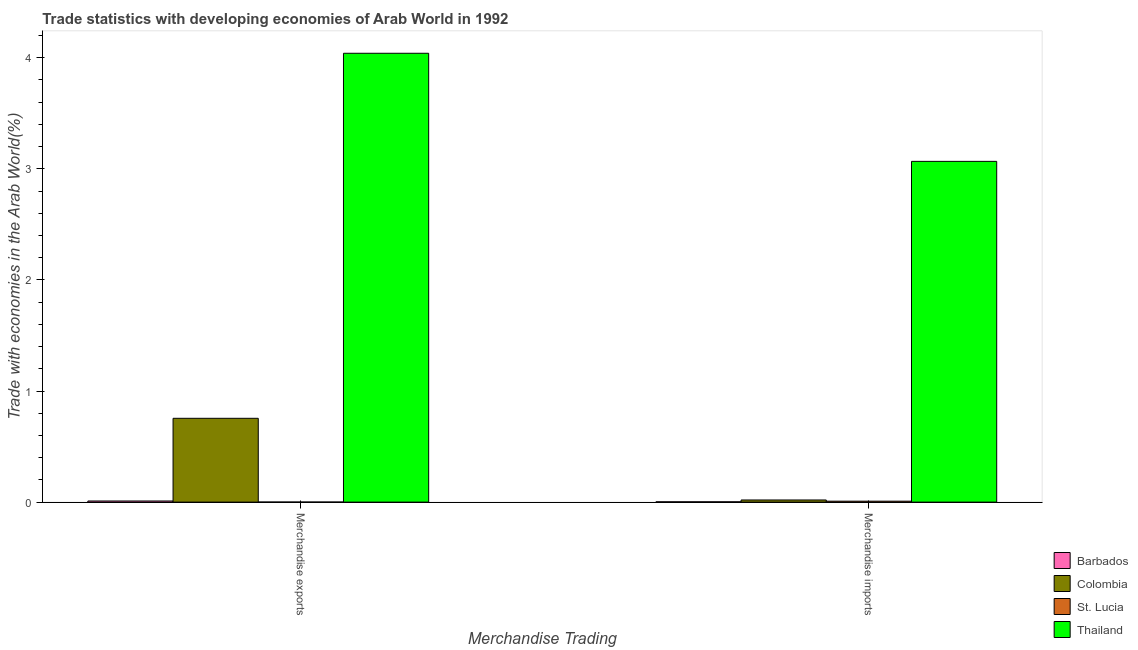How many different coloured bars are there?
Offer a very short reply. 4. How many groups of bars are there?
Ensure brevity in your answer.  2. Are the number of bars per tick equal to the number of legend labels?
Provide a short and direct response. Yes. How many bars are there on the 2nd tick from the right?
Make the answer very short. 4. What is the merchandise exports in Colombia?
Your answer should be compact. 0.75. Across all countries, what is the maximum merchandise exports?
Your answer should be very brief. 4.04. Across all countries, what is the minimum merchandise exports?
Keep it short and to the point. 0. In which country was the merchandise exports maximum?
Your response must be concise. Thailand. In which country was the merchandise imports minimum?
Your answer should be very brief. Barbados. What is the total merchandise exports in the graph?
Give a very brief answer. 4.8. What is the difference between the merchandise exports in Thailand and that in St. Lucia?
Offer a terse response. 4.04. What is the difference between the merchandise imports in St. Lucia and the merchandise exports in Colombia?
Your response must be concise. -0.75. What is the average merchandise imports per country?
Provide a succinct answer. 0.77. What is the difference between the merchandise imports and merchandise exports in Colombia?
Offer a terse response. -0.73. What is the ratio of the merchandise imports in Thailand to that in St. Lucia?
Provide a succinct answer. 362.38. What does the 1st bar from the right in Merchandise exports represents?
Your answer should be compact. Thailand. Are the values on the major ticks of Y-axis written in scientific E-notation?
Ensure brevity in your answer.  No. Does the graph contain grids?
Ensure brevity in your answer.  No. Where does the legend appear in the graph?
Offer a very short reply. Bottom right. What is the title of the graph?
Give a very brief answer. Trade statistics with developing economies of Arab World in 1992. What is the label or title of the X-axis?
Keep it short and to the point. Merchandise Trading. What is the label or title of the Y-axis?
Provide a succinct answer. Trade with economies in the Arab World(%). What is the Trade with economies in the Arab World(%) of Barbados in Merchandise exports?
Provide a succinct answer. 0.01. What is the Trade with economies in the Arab World(%) in Colombia in Merchandise exports?
Give a very brief answer. 0.75. What is the Trade with economies in the Arab World(%) in St. Lucia in Merchandise exports?
Keep it short and to the point. 0. What is the Trade with economies in the Arab World(%) of Thailand in Merchandise exports?
Your answer should be very brief. 4.04. What is the Trade with economies in the Arab World(%) of Barbados in Merchandise imports?
Offer a very short reply. 0. What is the Trade with economies in the Arab World(%) of Colombia in Merchandise imports?
Give a very brief answer. 0.02. What is the Trade with economies in the Arab World(%) of St. Lucia in Merchandise imports?
Your answer should be compact. 0.01. What is the Trade with economies in the Arab World(%) in Thailand in Merchandise imports?
Make the answer very short. 3.07. Across all Merchandise Trading, what is the maximum Trade with economies in the Arab World(%) in Barbados?
Your answer should be compact. 0.01. Across all Merchandise Trading, what is the maximum Trade with economies in the Arab World(%) of Colombia?
Your response must be concise. 0.75. Across all Merchandise Trading, what is the maximum Trade with economies in the Arab World(%) of St. Lucia?
Ensure brevity in your answer.  0.01. Across all Merchandise Trading, what is the maximum Trade with economies in the Arab World(%) of Thailand?
Your answer should be compact. 4.04. Across all Merchandise Trading, what is the minimum Trade with economies in the Arab World(%) in Barbados?
Provide a short and direct response. 0. Across all Merchandise Trading, what is the minimum Trade with economies in the Arab World(%) in Colombia?
Make the answer very short. 0.02. Across all Merchandise Trading, what is the minimum Trade with economies in the Arab World(%) in St. Lucia?
Offer a terse response. 0. Across all Merchandise Trading, what is the minimum Trade with economies in the Arab World(%) of Thailand?
Offer a very short reply. 3.07. What is the total Trade with economies in the Arab World(%) of Barbados in the graph?
Give a very brief answer. 0.01. What is the total Trade with economies in the Arab World(%) of Colombia in the graph?
Provide a short and direct response. 0.77. What is the total Trade with economies in the Arab World(%) of St. Lucia in the graph?
Give a very brief answer. 0.01. What is the total Trade with economies in the Arab World(%) of Thailand in the graph?
Give a very brief answer. 7.11. What is the difference between the Trade with economies in the Arab World(%) of Barbados in Merchandise exports and that in Merchandise imports?
Your response must be concise. 0.01. What is the difference between the Trade with economies in the Arab World(%) of Colombia in Merchandise exports and that in Merchandise imports?
Provide a succinct answer. 0.73. What is the difference between the Trade with economies in the Arab World(%) of St. Lucia in Merchandise exports and that in Merchandise imports?
Offer a very short reply. -0.01. What is the difference between the Trade with economies in the Arab World(%) of Thailand in Merchandise exports and that in Merchandise imports?
Ensure brevity in your answer.  0.97. What is the difference between the Trade with economies in the Arab World(%) of Barbados in Merchandise exports and the Trade with economies in the Arab World(%) of Colombia in Merchandise imports?
Your answer should be compact. -0.01. What is the difference between the Trade with economies in the Arab World(%) in Barbados in Merchandise exports and the Trade with economies in the Arab World(%) in St. Lucia in Merchandise imports?
Give a very brief answer. 0. What is the difference between the Trade with economies in the Arab World(%) in Barbados in Merchandise exports and the Trade with economies in the Arab World(%) in Thailand in Merchandise imports?
Provide a short and direct response. -3.06. What is the difference between the Trade with economies in the Arab World(%) of Colombia in Merchandise exports and the Trade with economies in the Arab World(%) of St. Lucia in Merchandise imports?
Provide a succinct answer. 0.75. What is the difference between the Trade with economies in the Arab World(%) of Colombia in Merchandise exports and the Trade with economies in the Arab World(%) of Thailand in Merchandise imports?
Give a very brief answer. -2.31. What is the difference between the Trade with economies in the Arab World(%) in St. Lucia in Merchandise exports and the Trade with economies in the Arab World(%) in Thailand in Merchandise imports?
Give a very brief answer. -3.07. What is the average Trade with economies in the Arab World(%) of Barbados per Merchandise Trading?
Your answer should be very brief. 0.01. What is the average Trade with economies in the Arab World(%) in Colombia per Merchandise Trading?
Your response must be concise. 0.39. What is the average Trade with economies in the Arab World(%) in St. Lucia per Merchandise Trading?
Offer a very short reply. 0. What is the average Trade with economies in the Arab World(%) of Thailand per Merchandise Trading?
Offer a terse response. 3.55. What is the difference between the Trade with economies in the Arab World(%) of Barbados and Trade with economies in the Arab World(%) of Colombia in Merchandise exports?
Keep it short and to the point. -0.74. What is the difference between the Trade with economies in the Arab World(%) in Barbados and Trade with economies in the Arab World(%) in St. Lucia in Merchandise exports?
Offer a terse response. 0.01. What is the difference between the Trade with economies in the Arab World(%) in Barbados and Trade with economies in the Arab World(%) in Thailand in Merchandise exports?
Your answer should be compact. -4.03. What is the difference between the Trade with economies in the Arab World(%) of Colombia and Trade with economies in the Arab World(%) of St. Lucia in Merchandise exports?
Your answer should be compact. 0.75. What is the difference between the Trade with economies in the Arab World(%) of Colombia and Trade with economies in the Arab World(%) of Thailand in Merchandise exports?
Make the answer very short. -3.29. What is the difference between the Trade with economies in the Arab World(%) of St. Lucia and Trade with economies in the Arab World(%) of Thailand in Merchandise exports?
Your response must be concise. -4.04. What is the difference between the Trade with economies in the Arab World(%) of Barbados and Trade with economies in the Arab World(%) of Colombia in Merchandise imports?
Your answer should be very brief. -0.02. What is the difference between the Trade with economies in the Arab World(%) of Barbados and Trade with economies in the Arab World(%) of St. Lucia in Merchandise imports?
Give a very brief answer. -0.01. What is the difference between the Trade with economies in the Arab World(%) in Barbados and Trade with economies in the Arab World(%) in Thailand in Merchandise imports?
Provide a succinct answer. -3.06. What is the difference between the Trade with economies in the Arab World(%) in Colombia and Trade with economies in the Arab World(%) in St. Lucia in Merchandise imports?
Provide a succinct answer. 0.01. What is the difference between the Trade with economies in the Arab World(%) in Colombia and Trade with economies in the Arab World(%) in Thailand in Merchandise imports?
Provide a succinct answer. -3.05. What is the difference between the Trade with economies in the Arab World(%) of St. Lucia and Trade with economies in the Arab World(%) of Thailand in Merchandise imports?
Your answer should be compact. -3.06. What is the ratio of the Trade with economies in the Arab World(%) of Barbados in Merchandise exports to that in Merchandise imports?
Your answer should be compact. 3.54. What is the ratio of the Trade with economies in the Arab World(%) in Colombia in Merchandise exports to that in Merchandise imports?
Your response must be concise. 39.02. What is the ratio of the Trade with economies in the Arab World(%) in St. Lucia in Merchandise exports to that in Merchandise imports?
Ensure brevity in your answer.  0.05. What is the ratio of the Trade with economies in the Arab World(%) in Thailand in Merchandise exports to that in Merchandise imports?
Your response must be concise. 1.32. What is the difference between the highest and the second highest Trade with economies in the Arab World(%) of Barbados?
Your answer should be very brief. 0.01. What is the difference between the highest and the second highest Trade with economies in the Arab World(%) in Colombia?
Make the answer very short. 0.73. What is the difference between the highest and the second highest Trade with economies in the Arab World(%) of St. Lucia?
Keep it short and to the point. 0.01. What is the difference between the highest and the second highest Trade with economies in the Arab World(%) of Thailand?
Make the answer very short. 0.97. What is the difference between the highest and the lowest Trade with economies in the Arab World(%) of Barbados?
Your answer should be very brief. 0.01. What is the difference between the highest and the lowest Trade with economies in the Arab World(%) of Colombia?
Offer a very short reply. 0.73. What is the difference between the highest and the lowest Trade with economies in the Arab World(%) in St. Lucia?
Provide a succinct answer. 0.01. What is the difference between the highest and the lowest Trade with economies in the Arab World(%) in Thailand?
Offer a very short reply. 0.97. 